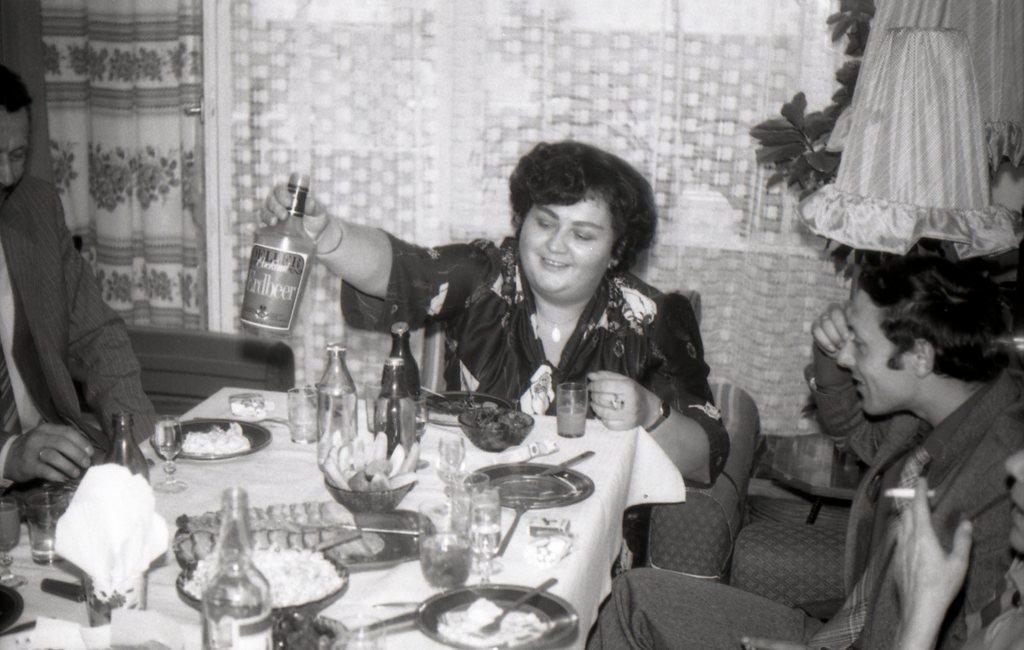Please provide a concise description of this image. In this image there are a group of people who are sitting on a chair. In front of them there is one table on that table there are some plates, bottles, and glasses are there and in the middle there is one basket and on the top there is a curtain. On the top of the right corner there is a plant. 